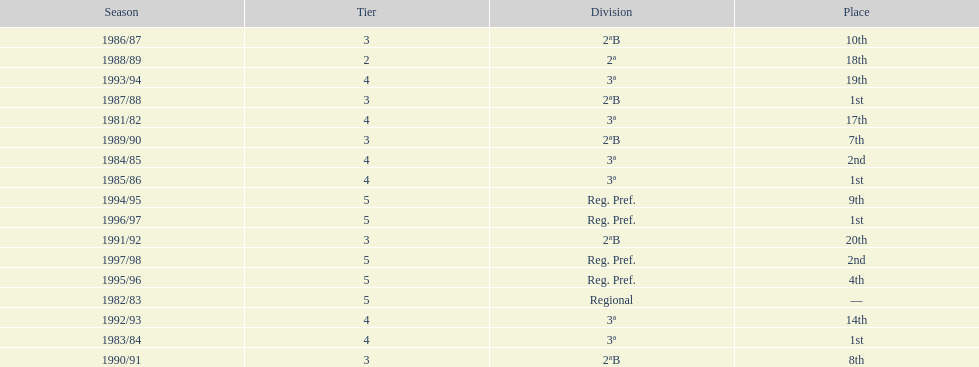How many times total did they finish first 4. 